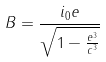<formula> <loc_0><loc_0><loc_500><loc_500>B = \frac { i _ { 0 } e } { \sqrt { 1 - \frac { e ^ { 3 } } { c ^ { 3 } } } }</formula> 